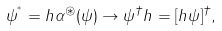<formula> <loc_0><loc_0><loc_500><loc_500>\psi ^ { ^ { * } } = h \alpha ^ { \circledast } ( \psi ) \rightarrow \psi ^ { \dagger } h = [ h \psi ] ^ { \dagger } ,</formula> 